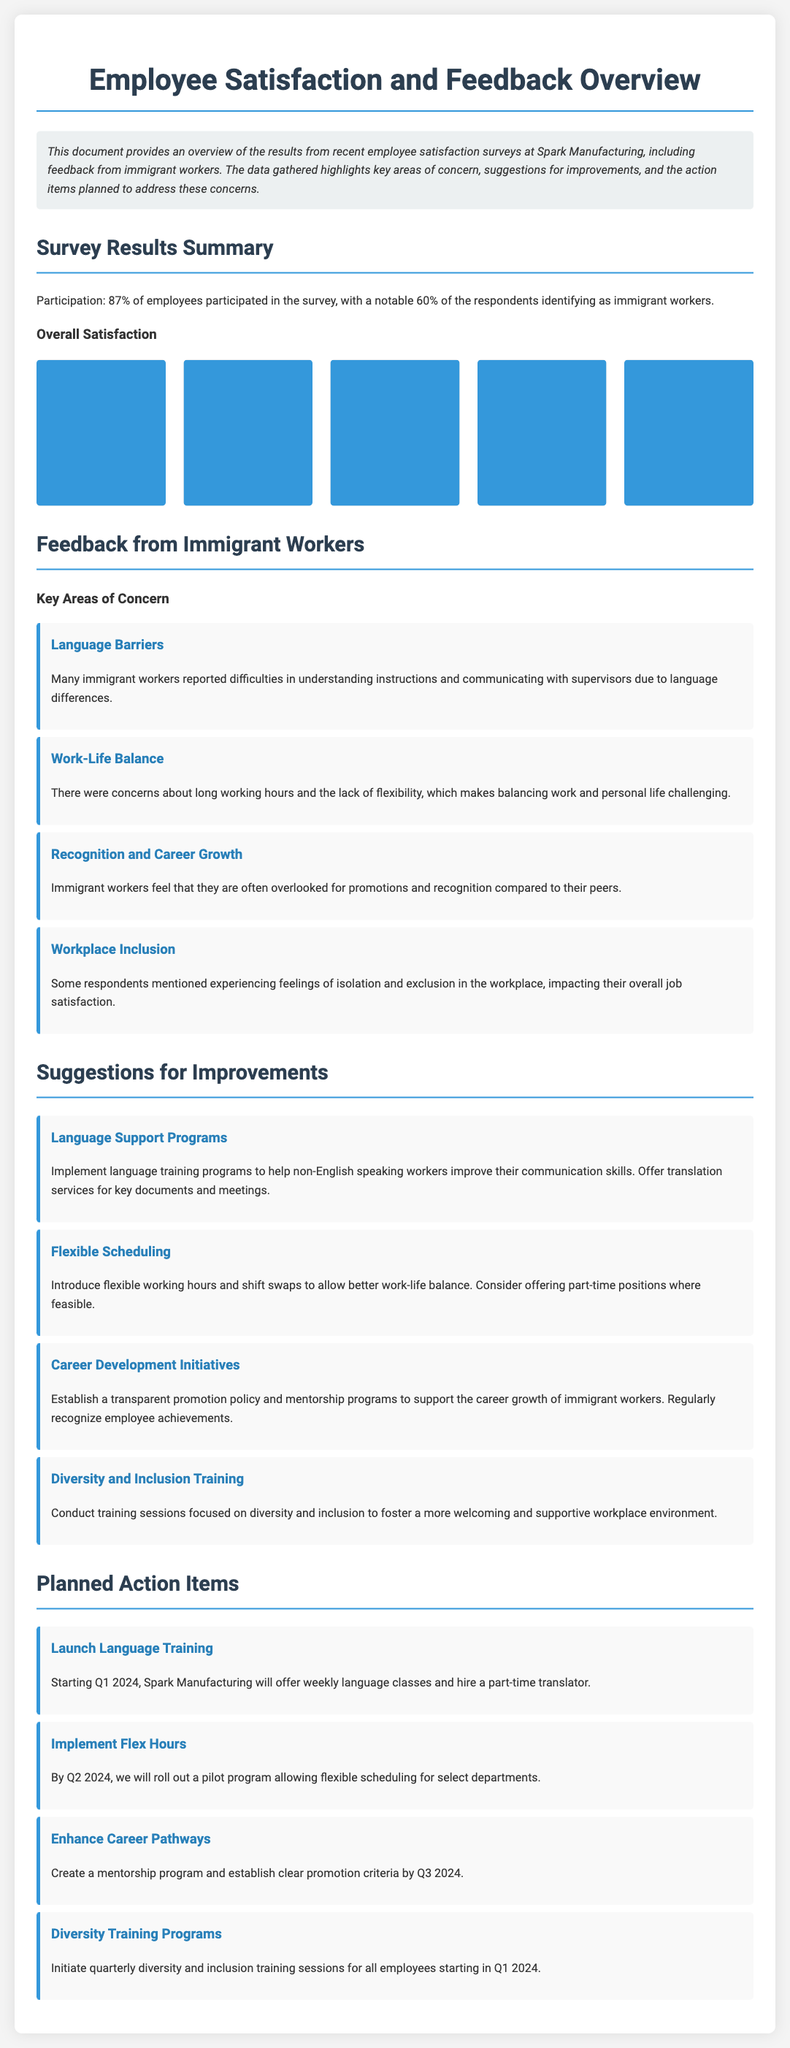What percentage of employees participated in the survey? The survey had a participation rate of 87% of employees.
Answer: 87% How many immigrant workers responded to the survey? 60% of the respondents identified as immigrant workers.
Answer: 60% What area received the highest satisfaction rating? The highest satisfaction rating was for 'Satisfied', with 45% of employees indicating this level of satisfaction.
Answer: Satisfied (45%) What key concern did many immigrant workers report? Many immigrant workers reported difficulties in understanding instructions and communicating with supervisors.
Answer: Language Barriers What is one suggestion for improving work-life balance? One suggestion is to introduce flexible working hours and shift swaps to allow better work-life balance.
Answer: Flexible Scheduling When will the language training program be launched? The language training program will launch in Q1 2024.
Answer: Q1 2024 What will be initiated starting in Q1 2024? Quarterly diversity and inclusion training sessions for all employees will be initiated starting in Q1 2024.
Answer: Diversity Training Programs Which concern relates to career growth for immigrant workers? The concern about being overlooked for promotions and recognition relates to career growth for immigrant workers.
Answer: Recognition and Career Growth What is a planned action item by Q3 2024? By Q3 2024, a mentorship program and clear promotion criteria will be established.
Answer: Enhance Career Pathways 